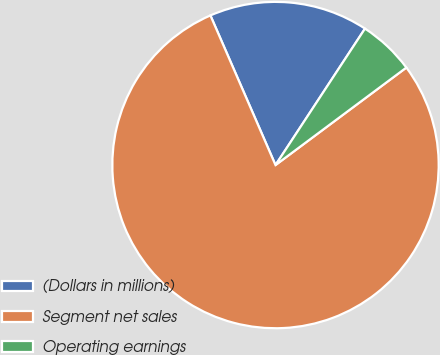Convert chart. <chart><loc_0><loc_0><loc_500><loc_500><pie_chart><fcel>(Dollars in millions)<fcel>Segment net sales<fcel>Operating earnings<nl><fcel>15.77%<fcel>78.66%<fcel>5.57%<nl></chart> 